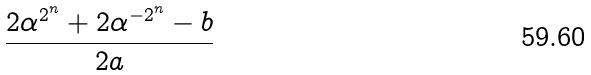<formula> <loc_0><loc_0><loc_500><loc_500>\frac { 2 \alpha ^ { 2 ^ { n } } + 2 \alpha ^ { - 2 ^ { n } } - b } { 2 a }</formula> 